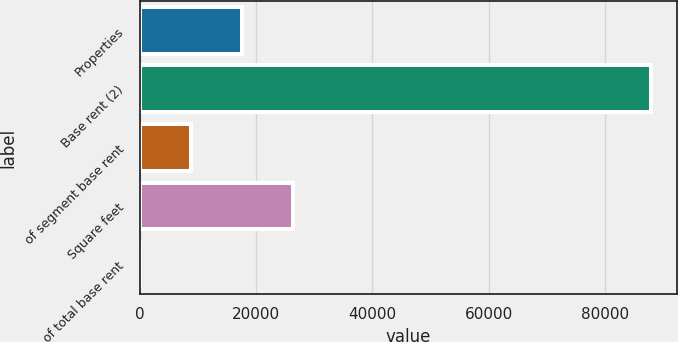<chart> <loc_0><loc_0><loc_500><loc_500><bar_chart><fcel>Properties<fcel>Base rent (2)<fcel>of segment base rent<fcel>Square feet<fcel>of total base rent<nl><fcel>17603.2<fcel>87960<fcel>8808.6<fcel>26397.8<fcel>14<nl></chart> 